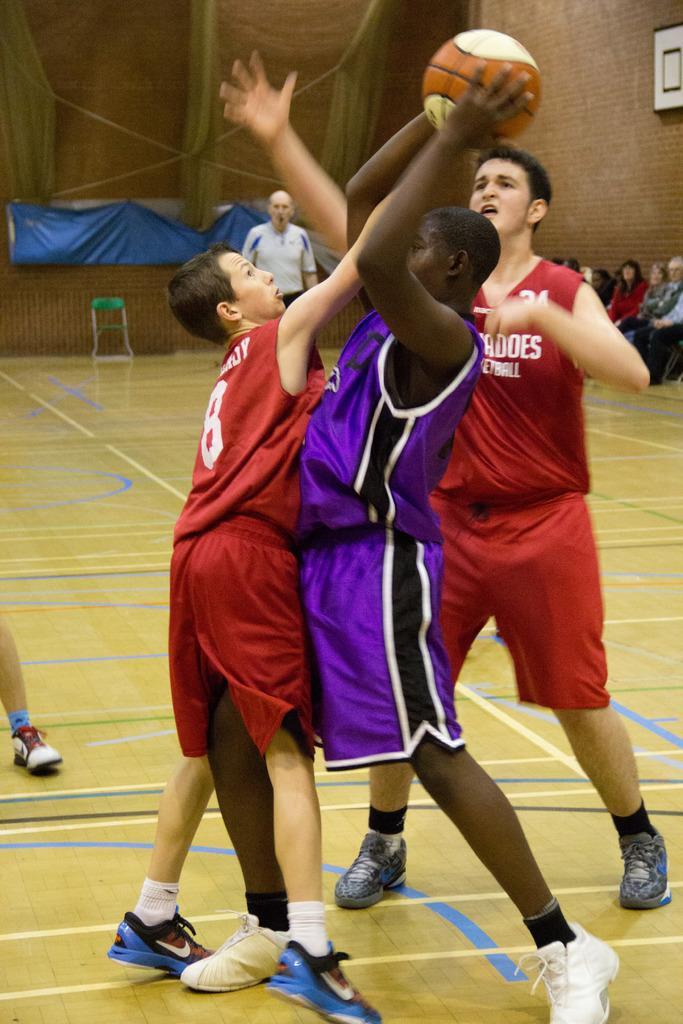Can you describe this image briefly? In this image I see 3 boys in which these both are wearing red color jersey and this boy is wearing violet and black color jersey and I see that this boy is holding a ball in his hands. In the background I see the basketball court and I see few more people and I see the wall and I see the blue color thing over here and I see a chair over here. 